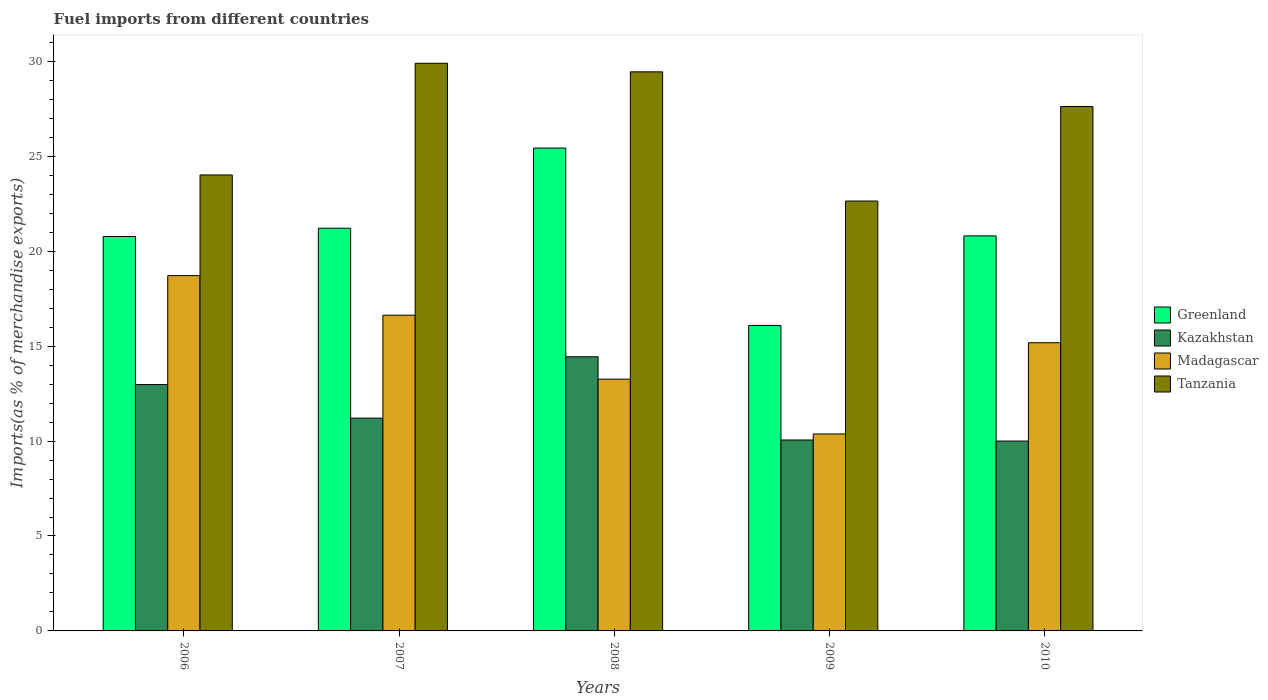How many different coloured bars are there?
Offer a very short reply. 4. How many groups of bars are there?
Your response must be concise. 5. Are the number of bars per tick equal to the number of legend labels?
Offer a very short reply. Yes. Are the number of bars on each tick of the X-axis equal?
Make the answer very short. Yes. How many bars are there on the 5th tick from the left?
Offer a very short reply. 4. How many bars are there on the 5th tick from the right?
Make the answer very short. 4. What is the label of the 1st group of bars from the left?
Offer a very short reply. 2006. In how many cases, is the number of bars for a given year not equal to the number of legend labels?
Your answer should be compact. 0. What is the percentage of imports to different countries in Tanzania in 2007?
Ensure brevity in your answer.  29.9. Across all years, what is the maximum percentage of imports to different countries in Tanzania?
Your answer should be very brief. 29.9. Across all years, what is the minimum percentage of imports to different countries in Greenland?
Provide a short and direct response. 16.09. In which year was the percentage of imports to different countries in Madagascar maximum?
Offer a terse response. 2006. In which year was the percentage of imports to different countries in Madagascar minimum?
Your response must be concise. 2009. What is the total percentage of imports to different countries in Madagascar in the graph?
Make the answer very short. 74.16. What is the difference between the percentage of imports to different countries in Greenland in 2008 and that in 2009?
Offer a very short reply. 9.34. What is the difference between the percentage of imports to different countries in Tanzania in 2009 and the percentage of imports to different countries in Kazakhstan in 2006?
Make the answer very short. 9.66. What is the average percentage of imports to different countries in Madagascar per year?
Keep it short and to the point. 14.83. In the year 2010, what is the difference between the percentage of imports to different countries in Tanzania and percentage of imports to different countries in Madagascar?
Your answer should be very brief. 12.44. In how many years, is the percentage of imports to different countries in Tanzania greater than 12 %?
Provide a short and direct response. 5. What is the ratio of the percentage of imports to different countries in Tanzania in 2006 to that in 2010?
Give a very brief answer. 0.87. Is the percentage of imports to different countries in Madagascar in 2006 less than that in 2007?
Offer a terse response. No. What is the difference between the highest and the second highest percentage of imports to different countries in Kazakhstan?
Your answer should be very brief. 1.46. What is the difference between the highest and the lowest percentage of imports to different countries in Tanzania?
Make the answer very short. 7.26. Is it the case that in every year, the sum of the percentage of imports to different countries in Tanzania and percentage of imports to different countries in Kazakhstan is greater than the sum of percentage of imports to different countries in Greenland and percentage of imports to different countries in Madagascar?
Give a very brief answer. Yes. What does the 1st bar from the left in 2006 represents?
Offer a terse response. Greenland. What does the 1st bar from the right in 2009 represents?
Keep it short and to the point. Tanzania. Are all the bars in the graph horizontal?
Provide a short and direct response. No. What is the difference between two consecutive major ticks on the Y-axis?
Your answer should be compact. 5. Are the values on the major ticks of Y-axis written in scientific E-notation?
Provide a succinct answer. No. What is the title of the graph?
Make the answer very short. Fuel imports from different countries. Does "Zambia" appear as one of the legend labels in the graph?
Your answer should be very brief. No. What is the label or title of the X-axis?
Give a very brief answer. Years. What is the label or title of the Y-axis?
Offer a very short reply. Imports(as % of merchandise exports). What is the Imports(as % of merchandise exports) in Greenland in 2006?
Ensure brevity in your answer.  20.77. What is the Imports(as % of merchandise exports) of Kazakhstan in 2006?
Ensure brevity in your answer.  12.98. What is the Imports(as % of merchandise exports) in Madagascar in 2006?
Keep it short and to the point. 18.71. What is the Imports(as % of merchandise exports) of Tanzania in 2006?
Your answer should be compact. 24.02. What is the Imports(as % of merchandise exports) in Greenland in 2007?
Provide a succinct answer. 21.21. What is the Imports(as % of merchandise exports) in Kazakhstan in 2007?
Ensure brevity in your answer.  11.21. What is the Imports(as % of merchandise exports) in Madagascar in 2007?
Provide a succinct answer. 16.63. What is the Imports(as % of merchandise exports) in Tanzania in 2007?
Provide a short and direct response. 29.9. What is the Imports(as % of merchandise exports) in Greenland in 2008?
Your answer should be very brief. 25.43. What is the Imports(as % of merchandise exports) in Kazakhstan in 2008?
Provide a short and direct response. 14.44. What is the Imports(as % of merchandise exports) of Madagascar in 2008?
Offer a terse response. 13.26. What is the Imports(as % of merchandise exports) in Tanzania in 2008?
Make the answer very short. 29.45. What is the Imports(as % of merchandise exports) of Greenland in 2009?
Keep it short and to the point. 16.09. What is the Imports(as % of merchandise exports) in Kazakhstan in 2009?
Your answer should be very brief. 10.06. What is the Imports(as % of merchandise exports) in Madagascar in 2009?
Give a very brief answer. 10.37. What is the Imports(as % of merchandise exports) of Tanzania in 2009?
Keep it short and to the point. 22.64. What is the Imports(as % of merchandise exports) of Greenland in 2010?
Give a very brief answer. 20.81. What is the Imports(as % of merchandise exports) in Kazakhstan in 2010?
Provide a short and direct response. 10. What is the Imports(as % of merchandise exports) of Madagascar in 2010?
Offer a very short reply. 15.18. What is the Imports(as % of merchandise exports) of Tanzania in 2010?
Offer a terse response. 27.62. Across all years, what is the maximum Imports(as % of merchandise exports) of Greenland?
Offer a terse response. 25.43. Across all years, what is the maximum Imports(as % of merchandise exports) of Kazakhstan?
Provide a short and direct response. 14.44. Across all years, what is the maximum Imports(as % of merchandise exports) of Madagascar?
Offer a very short reply. 18.71. Across all years, what is the maximum Imports(as % of merchandise exports) in Tanzania?
Your response must be concise. 29.9. Across all years, what is the minimum Imports(as % of merchandise exports) in Greenland?
Provide a succinct answer. 16.09. Across all years, what is the minimum Imports(as % of merchandise exports) in Kazakhstan?
Give a very brief answer. 10. Across all years, what is the minimum Imports(as % of merchandise exports) of Madagascar?
Offer a terse response. 10.37. Across all years, what is the minimum Imports(as % of merchandise exports) in Tanzania?
Your answer should be compact. 22.64. What is the total Imports(as % of merchandise exports) in Greenland in the graph?
Provide a short and direct response. 104.31. What is the total Imports(as % of merchandise exports) of Kazakhstan in the graph?
Offer a very short reply. 58.68. What is the total Imports(as % of merchandise exports) in Madagascar in the graph?
Offer a very short reply. 74.16. What is the total Imports(as % of merchandise exports) of Tanzania in the graph?
Your answer should be compact. 133.62. What is the difference between the Imports(as % of merchandise exports) in Greenland in 2006 and that in 2007?
Give a very brief answer. -0.44. What is the difference between the Imports(as % of merchandise exports) of Kazakhstan in 2006 and that in 2007?
Give a very brief answer. 1.77. What is the difference between the Imports(as % of merchandise exports) of Madagascar in 2006 and that in 2007?
Ensure brevity in your answer.  2.09. What is the difference between the Imports(as % of merchandise exports) of Tanzania in 2006 and that in 2007?
Provide a short and direct response. -5.88. What is the difference between the Imports(as % of merchandise exports) in Greenland in 2006 and that in 2008?
Offer a terse response. -4.66. What is the difference between the Imports(as % of merchandise exports) in Kazakhstan in 2006 and that in 2008?
Make the answer very short. -1.46. What is the difference between the Imports(as % of merchandise exports) in Madagascar in 2006 and that in 2008?
Give a very brief answer. 5.45. What is the difference between the Imports(as % of merchandise exports) of Tanzania in 2006 and that in 2008?
Offer a terse response. -5.43. What is the difference between the Imports(as % of merchandise exports) in Greenland in 2006 and that in 2009?
Ensure brevity in your answer.  4.69. What is the difference between the Imports(as % of merchandise exports) in Kazakhstan in 2006 and that in 2009?
Provide a short and direct response. 2.92. What is the difference between the Imports(as % of merchandise exports) of Madagascar in 2006 and that in 2009?
Give a very brief answer. 8.34. What is the difference between the Imports(as % of merchandise exports) in Tanzania in 2006 and that in 2009?
Keep it short and to the point. 1.37. What is the difference between the Imports(as % of merchandise exports) in Greenland in 2006 and that in 2010?
Give a very brief answer. -0.03. What is the difference between the Imports(as % of merchandise exports) of Kazakhstan in 2006 and that in 2010?
Your answer should be compact. 2.98. What is the difference between the Imports(as % of merchandise exports) in Madagascar in 2006 and that in 2010?
Offer a very short reply. 3.54. What is the difference between the Imports(as % of merchandise exports) of Tanzania in 2006 and that in 2010?
Your answer should be very brief. -3.6. What is the difference between the Imports(as % of merchandise exports) in Greenland in 2007 and that in 2008?
Your answer should be compact. -4.22. What is the difference between the Imports(as % of merchandise exports) in Kazakhstan in 2007 and that in 2008?
Keep it short and to the point. -3.23. What is the difference between the Imports(as % of merchandise exports) in Madagascar in 2007 and that in 2008?
Keep it short and to the point. 3.37. What is the difference between the Imports(as % of merchandise exports) in Tanzania in 2007 and that in 2008?
Offer a terse response. 0.45. What is the difference between the Imports(as % of merchandise exports) in Greenland in 2007 and that in 2009?
Your response must be concise. 5.12. What is the difference between the Imports(as % of merchandise exports) in Kazakhstan in 2007 and that in 2009?
Keep it short and to the point. 1.15. What is the difference between the Imports(as % of merchandise exports) of Madagascar in 2007 and that in 2009?
Your answer should be very brief. 6.25. What is the difference between the Imports(as % of merchandise exports) of Tanzania in 2007 and that in 2009?
Provide a succinct answer. 7.26. What is the difference between the Imports(as % of merchandise exports) in Greenland in 2007 and that in 2010?
Provide a short and direct response. 0.4. What is the difference between the Imports(as % of merchandise exports) of Kazakhstan in 2007 and that in 2010?
Offer a terse response. 1.21. What is the difference between the Imports(as % of merchandise exports) of Madagascar in 2007 and that in 2010?
Your answer should be compact. 1.45. What is the difference between the Imports(as % of merchandise exports) in Tanzania in 2007 and that in 2010?
Offer a terse response. 2.28. What is the difference between the Imports(as % of merchandise exports) in Greenland in 2008 and that in 2009?
Offer a terse response. 9.34. What is the difference between the Imports(as % of merchandise exports) of Kazakhstan in 2008 and that in 2009?
Offer a very short reply. 4.38. What is the difference between the Imports(as % of merchandise exports) in Madagascar in 2008 and that in 2009?
Offer a very short reply. 2.89. What is the difference between the Imports(as % of merchandise exports) in Tanzania in 2008 and that in 2009?
Your answer should be compact. 6.8. What is the difference between the Imports(as % of merchandise exports) of Greenland in 2008 and that in 2010?
Offer a terse response. 4.62. What is the difference between the Imports(as % of merchandise exports) of Kazakhstan in 2008 and that in 2010?
Offer a very short reply. 4.44. What is the difference between the Imports(as % of merchandise exports) in Madagascar in 2008 and that in 2010?
Provide a succinct answer. -1.92. What is the difference between the Imports(as % of merchandise exports) in Tanzania in 2008 and that in 2010?
Give a very brief answer. 1.83. What is the difference between the Imports(as % of merchandise exports) of Greenland in 2009 and that in 2010?
Provide a succinct answer. -4.72. What is the difference between the Imports(as % of merchandise exports) in Kazakhstan in 2009 and that in 2010?
Your answer should be compact. 0.06. What is the difference between the Imports(as % of merchandise exports) in Madagascar in 2009 and that in 2010?
Give a very brief answer. -4.8. What is the difference between the Imports(as % of merchandise exports) of Tanzania in 2009 and that in 2010?
Offer a terse response. -4.98. What is the difference between the Imports(as % of merchandise exports) of Greenland in 2006 and the Imports(as % of merchandise exports) of Kazakhstan in 2007?
Your answer should be very brief. 9.57. What is the difference between the Imports(as % of merchandise exports) in Greenland in 2006 and the Imports(as % of merchandise exports) in Madagascar in 2007?
Provide a succinct answer. 4.15. What is the difference between the Imports(as % of merchandise exports) in Greenland in 2006 and the Imports(as % of merchandise exports) in Tanzania in 2007?
Ensure brevity in your answer.  -9.12. What is the difference between the Imports(as % of merchandise exports) of Kazakhstan in 2006 and the Imports(as % of merchandise exports) of Madagascar in 2007?
Offer a terse response. -3.65. What is the difference between the Imports(as % of merchandise exports) in Kazakhstan in 2006 and the Imports(as % of merchandise exports) in Tanzania in 2007?
Give a very brief answer. -16.92. What is the difference between the Imports(as % of merchandise exports) in Madagascar in 2006 and the Imports(as % of merchandise exports) in Tanzania in 2007?
Provide a short and direct response. -11.18. What is the difference between the Imports(as % of merchandise exports) in Greenland in 2006 and the Imports(as % of merchandise exports) in Kazakhstan in 2008?
Provide a succinct answer. 6.33. What is the difference between the Imports(as % of merchandise exports) in Greenland in 2006 and the Imports(as % of merchandise exports) in Madagascar in 2008?
Keep it short and to the point. 7.51. What is the difference between the Imports(as % of merchandise exports) in Greenland in 2006 and the Imports(as % of merchandise exports) in Tanzania in 2008?
Provide a succinct answer. -8.67. What is the difference between the Imports(as % of merchandise exports) in Kazakhstan in 2006 and the Imports(as % of merchandise exports) in Madagascar in 2008?
Your answer should be compact. -0.28. What is the difference between the Imports(as % of merchandise exports) in Kazakhstan in 2006 and the Imports(as % of merchandise exports) in Tanzania in 2008?
Provide a succinct answer. -16.47. What is the difference between the Imports(as % of merchandise exports) in Madagascar in 2006 and the Imports(as % of merchandise exports) in Tanzania in 2008?
Make the answer very short. -10.73. What is the difference between the Imports(as % of merchandise exports) of Greenland in 2006 and the Imports(as % of merchandise exports) of Kazakhstan in 2009?
Provide a succinct answer. 10.72. What is the difference between the Imports(as % of merchandise exports) of Greenland in 2006 and the Imports(as % of merchandise exports) of Madagascar in 2009?
Your response must be concise. 10.4. What is the difference between the Imports(as % of merchandise exports) in Greenland in 2006 and the Imports(as % of merchandise exports) in Tanzania in 2009?
Give a very brief answer. -1.87. What is the difference between the Imports(as % of merchandise exports) of Kazakhstan in 2006 and the Imports(as % of merchandise exports) of Madagascar in 2009?
Offer a very short reply. 2.6. What is the difference between the Imports(as % of merchandise exports) in Kazakhstan in 2006 and the Imports(as % of merchandise exports) in Tanzania in 2009?
Offer a very short reply. -9.66. What is the difference between the Imports(as % of merchandise exports) of Madagascar in 2006 and the Imports(as % of merchandise exports) of Tanzania in 2009?
Provide a succinct answer. -3.93. What is the difference between the Imports(as % of merchandise exports) in Greenland in 2006 and the Imports(as % of merchandise exports) in Kazakhstan in 2010?
Provide a short and direct response. 10.77. What is the difference between the Imports(as % of merchandise exports) of Greenland in 2006 and the Imports(as % of merchandise exports) of Madagascar in 2010?
Provide a short and direct response. 5.6. What is the difference between the Imports(as % of merchandise exports) in Greenland in 2006 and the Imports(as % of merchandise exports) in Tanzania in 2010?
Make the answer very short. -6.85. What is the difference between the Imports(as % of merchandise exports) of Kazakhstan in 2006 and the Imports(as % of merchandise exports) of Madagascar in 2010?
Give a very brief answer. -2.2. What is the difference between the Imports(as % of merchandise exports) in Kazakhstan in 2006 and the Imports(as % of merchandise exports) in Tanzania in 2010?
Your answer should be very brief. -14.64. What is the difference between the Imports(as % of merchandise exports) in Madagascar in 2006 and the Imports(as % of merchandise exports) in Tanzania in 2010?
Offer a very short reply. -8.91. What is the difference between the Imports(as % of merchandise exports) in Greenland in 2007 and the Imports(as % of merchandise exports) in Kazakhstan in 2008?
Provide a short and direct response. 6.77. What is the difference between the Imports(as % of merchandise exports) of Greenland in 2007 and the Imports(as % of merchandise exports) of Madagascar in 2008?
Offer a very short reply. 7.95. What is the difference between the Imports(as % of merchandise exports) of Greenland in 2007 and the Imports(as % of merchandise exports) of Tanzania in 2008?
Offer a very short reply. -8.24. What is the difference between the Imports(as % of merchandise exports) of Kazakhstan in 2007 and the Imports(as % of merchandise exports) of Madagascar in 2008?
Ensure brevity in your answer.  -2.05. What is the difference between the Imports(as % of merchandise exports) in Kazakhstan in 2007 and the Imports(as % of merchandise exports) in Tanzania in 2008?
Keep it short and to the point. -18.24. What is the difference between the Imports(as % of merchandise exports) of Madagascar in 2007 and the Imports(as % of merchandise exports) of Tanzania in 2008?
Offer a very short reply. -12.82. What is the difference between the Imports(as % of merchandise exports) of Greenland in 2007 and the Imports(as % of merchandise exports) of Kazakhstan in 2009?
Offer a very short reply. 11.15. What is the difference between the Imports(as % of merchandise exports) in Greenland in 2007 and the Imports(as % of merchandise exports) in Madagascar in 2009?
Offer a very short reply. 10.83. What is the difference between the Imports(as % of merchandise exports) of Greenland in 2007 and the Imports(as % of merchandise exports) of Tanzania in 2009?
Your answer should be very brief. -1.43. What is the difference between the Imports(as % of merchandise exports) in Kazakhstan in 2007 and the Imports(as % of merchandise exports) in Madagascar in 2009?
Your answer should be compact. 0.83. What is the difference between the Imports(as % of merchandise exports) of Kazakhstan in 2007 and the Imports(as % of merchandise exports) of Tanzania in 2009?
Provide a short and direct response. -11.43. What is the difference between the Imports(as % of merchandise exports) of Madagascar in 2007 and the Imports(as % of merchandise exports) of Tanzania in 2009?
Keep it short and to the point. -6.01. What is the difference between the Imports(as % of merchandise exports) in Greenland in 2007 and the Imports(as % of merchandise exports) in Kazakhstan in 2010?
Your response must be concise. 11.21. What is the difference between the Imports(as % of merchandise exports) in Greenland in 2007 and the Imports(as % of merchandise exports) in Madagascar in 2010?
Your answer should be compact. 6.03. What is the difference between the Imports(as % of merchandise exports) in Greenland in 2007 and the Imports(as % of merchandise exports) in Tanzania in 2010?
Your answer should be compact. -6.41. What is the difference between the Imports(as % of merchandise exports) in Kazakhstan in 2007 and the Imports(as % of merchandise exports) in Madagascar in 2010?
Give a very brief answer. -3.97. What is the difference between the Imports(as % of merchandise exports) of Kazakhstan in 2007 and the Imports(as % of merchandise exports) of Tanzania in 2010?
Your answer should be very brief. -16.41. What is the difference between the Imports(as % of merchandise exports) in Madagascar in 2007 and the Imports(as % of merchandise exports) in Tanzania in 2010?
Your response must be concise. -10.99. What is the difference between the Imports(as % of merchandise exports) in Greenland in 2008 and the Imports(as % of merchandise exports) in Kazakhstan in 2009?
Offer a terse response. 15.38. What is the difference between the Imports(as % of merchandise exports) of Greenland in 2008 and the Imports(as % of merchandise exports) of Madagascar in 2009?
Your answer should be very brief. 15.06. What is the difference between the Imports(as % of merchandise exports) in Greenland in 2008 and the Imports(as % of merchandise exports) in Tanzania in 2009?
Offer a terse response. 2.79. What is the difference between the Imports(as % of merchandise exports) in Kazakhstan in 2008 and the Imports(as % of merchandise exports) in Madagascar in 2009?
Give a very brief answer. 4.06. What is the difference between the Imports(as % of merchandise exports) in Kazakhstan in 2008 and the Imports(as % of merchandise exports) in Tanzania in 2009?
Your answer should be very brief. -8.2. What is the difference between the Imports(as % of merchandise exports) of Madagascar in 2008 and the Imports(as % of merchandise exports) of Tanzania in 2009?
Ensure brevity in your answer.  -9.38. What is the difference between the Imports(as % of merchandise exports) of Greenland in 2008 and the Imports(as % of merchandise exports) of Kazakhstan in 2010?
Provide a short and direct response. 15.43. What is the difference between the Imports(as % of merchandise exports) of Greenland in 2008 and the Imports(as % of merchandise exports) of Madagascar in 2010?
Provide a succinct answer. 10.25. What is the difference between the Imports(as % of merchandise exports) of Greenland in 2008 and the Imports(as % of merchandise exports) of Tanzania in 2010?
Your answer should be compact. -2.19. What is the difference between the Imports(as % of merchandise exports) in Kazakhstan in 2008 and the Imports(as % of merchandise exports) in Madagascar in 2010?
Offer a very short reply. -0.74. What is the difference between the Imports(as % of merchandise exports) in Kazakhstan in 2008 and the Imports(as % of merchandise exports) in Tanzania in 2010?
Your answer should be very brief. -13.18. What is the difference between the Imports(as % of merchandise exports) of Madagascar in 2008 and the Imports(as % of merchandise exports) of Tanzania in 2010?
Your response must be concise. -14.36. What is the difference between the Imports(as % of merchandise exports) of Greenland in 2009 and the Imports(as % of merchandise exports) of Kazakhstan in 2010?
Offer a very short reply. 6.09. What is the difference between the Imports(as % of merchandise exports) of Greenland in 2009 and the Imports(as % of merchandise exports) of Madagascar in 2010?
Your answer should be compact. 0.91. What is the difference between the Imports(as % of merchandise exports) in Greenland in 2009 and the Imports(as % of merchandise exports) in Tanzania in 2010?
Your answer should be very brief. -11.53. What is the difference between the Imports(as % of merchandise exports) of Kazakhstan in 2009 and the Imports(as % of merchandise exports) of Madagascar in 2010?
Give a very brief answer. -5.12. What is the difference between the Imports(as % of merchandise exports) of Kazakhstan in 2009 and the Imports(as % of merchandise exports) of Tanzania in 2010?
Give a very brief answer. -17.56. What is the difference between the Imports(as % of merchandise exports) in Madagascar in 2009 and the Imports(as % of merchandise exports) in Tanzania in 2010?
Provide a short and direct response. -17.24. What is the average Imports(as % of merchandise exports) in Greenland per year?
Your response must be concise. 20.86. What is the average Imports(as % of merchandise exports) of Kazakhstan per year?
Give a very brief answer. 11.74. What is the average Imports(as % of merchandise exports) of Madagascar per year?
Offer a very short reply. 14.83. What is the average Imports(as % of merchandise exports) in Tanzania per year?
Your response must be concise. 26.72. In the year 2006, what is the difference between the Imports(as % of merchandise exports) of Greenland and Imports(as % of merchandise exports) of Kazakhstan?
Your response must be concise. 7.8. In the year 2006, what is the difference between the Imports(as % of merchandise exports) of Greenland and Imports(as % of merchandise exports) of Madagascar?
Give a very brief answer. 2.06. In the year 2006, what is the difference between the Imports(as % of merchandise exports) in Greenland and Imports(as % of merchandise exports) in Tanzania?
Ensure brevity in your answer.  -3.24. In the year 2006, what is the difference between the Imports(as % of merchandise exports) in Kazakhstan and Imports(as % of merchandise exports) in Madagascar?
Make the answer very short. -5.74. In the year 2006, what is the difference between the Imports(as % of merchandise exports) of Kazakhstan and Imports(as % of merchandise exports) of Tanzania?
Your answer should be compact. -11.04. In the year 2006, what is the difference between the Imports(as % of merchandise exports) of Madagascar and Imports(as % of merchandise exports) of Tanzania?
Your answer should be compact. -5.3. In the year 2007, what is the difference between the Imports(as % of merchandise exports) in Greenland and Imports(as % of merchandise exports) in Kazakhstan?
Your response must be concise. 10. In the year 2007, what is the difference between the Imports(as % of merchandise exports) of Greenland and Imports(as % of merchandise exports) of Madagascar?
Ensure brevity in your answer.  4.58. In the year 2007, what is the difference between the Imports(as % of merchandise exports) in Greenland and Imports(as % of merchandise exports) in Tanzania?
Your answer should be compact. -8.69. In the year 2007, what is the difference between the Imports(as % of merchandise exports) of Kazakhstan and Imports(as % of merchandise exports) of Madagascar?
Keep it short and to the point. -5.42. In the year 2007, what is the difference between the Imports(as % of merchandise exports) in Kazakhstan and Imports(as % of merchandise exports) in Tanzania?
Offer a very short reply. -18.69. In the year 2007, what is the difference between the Imports(as % of merchandise exports) of Madagascar and Imports(as % of merchandise exports) of Tanzania?
Your answer should be very brief. -13.27. In the year 2008, what is the difference between the Imports(as % of merchandise exports) in Greenland and Imports(as % of merchandise exports) in Kazakhstan?
Provide a short and direct response. 10.99. In the year 2008, what is the difference between the Imports(as % of merchandise exports) of Greenland and Imports(as % of merchandise exports) of Madagascar?
Give a very brief answer. 12.17. In the year 2008, what is the difference between the Imports(as % of merchandise exports) of Greenland and Imports(as % of merchandise exports) of Tanzania?
Your response must be concise. -4.01. In the year 2008, what is the difference between the Imports(as % of merchandise exports) of Kazakhstan and Imports(as % of merchandise exports) of Madagascar?
Ensure brevity in your answer.  1.18. In the year 2008, what is the difference between the Imports(as % of merchandise exports) in Kazakhstan and Imports(as % of merchandise exports) in Tanzania?
Your answer should be compact. -15.01. In the year 2008, what is the difference between the Imports(as % of merchandise exports) in Madagascar and Imports(as % of merchandise exports) in Tanzania?
Provide a succinct answer. -16.18. In the year 2009, what is the difference between the Imports(as % of merchandise exports) of Greenland and Imports(as % of merchandise exports) of Kazakhstan?
Keep it short and to the point. 6.03. In the year 2009, what is the difference between the Imports(as % of merchandise exports) of Greenland and Imports(as % of merchandise exports) of Madagascar?
Provide a succinct answer. 5.71. In the year 2009, what is the difference between the Imports(as % of merchandise exports) in Greenland and Imports(as % of merchandise exports) in Tanzania?
Keep it short and to the point. -6.55. In the year 2009, what is the difference between the Imports(as % of merchandise exports) of Kazakhstan and Imports(as % of merchandise exports) of Madagascar?
Give a very brief answer. -0.32. In the year 2009, what is the difference between the Imports(as % of merchandise exports) in Kazakhstan and Imports(as % of merchandise exports) in Tanzania?
Offer a terse response. -12.59. In the year 2009, what is the difference between the Imports(as % of merchandise exports) of Madagascar and Imports(as % of merchandise exports) of Tanzania?
Provide a succinct answer. -12.27. In the year 2010, what is the difference between the Imports(as % of merchandise exports) in Greenland and Imports(as % of merchandise exports) in Kazakhstan?
Offer a terse response. 10.81. In the year 2010, what is the difference between the Imports(as % of merchandise exports) of Greenland and Imports(as % of merchandise exports) of Madagascar?
Provide a short and direct response. 5.63. In the year 2010, what is the difference between the Imports(as % of merchandise exports) of Greenland and Imports(as % of merchandise exports) of Tanzania?
Offer a terse response. -6.81. In the year 2010, what is the difference between the Imports(as % of merchandise exports) in Kazakhstan and Imports(as % of merchandise exports) in Madagascar?
Make the answer very short. -5.18. In the year 2010, what is the difference between the Imports(as % of merchandise exports) in Kazakhstan and Imports(as % of merchandise exports) in Tanzania?
Your response must be concise. -17.62. In the year 2010, what is the difference between the Imports(as % of merchandise exports) in Madagascar and Imports(as % of merchandise exports) in Tanzania?
Give a very brief answer. -12.44. What is the ratio of the Imports(as % of merchandise exports) in Greenland in 2006 to that in 2007?
Provide a succinct answer. 0.98. What is the ratio of the Imports(as % of merchandise exports) in Kazakhstan in 2006 to that in 2007?
Your response must be concise. 1.16. What is the ratio of the Imports(as % of merchandise exports) of Madagascar in 2006 to that in 2007?
Give a very brief answer. 1.13. What is the ratio of the Imports(as % of merchandise exports) of Tanzania in 2006 to that in 2007?
Provide a succinct answer. 0.8. What is the ratio of the Imports(as % of merchandise exports) of Greenland in 2006 to that in 2008?
Your response must be concise. 0.82. What is the ratio of the Imports(as % of merchandise exports) in Kazakhstan in 2006 to that in 2008?
Give a very brief answer. 0.9. What is the ratio of the Imports(as % of merchandise exports) in Madagascar in 2006 to that in 2008?
Ensure brevity in your answer.  1.41. What is the ratio of the Imports(as % of merchandise exports) of Tanzania in 2006 to that in 2008?
Provide a succinct answer. 0.82. What is the ratio of the Imports(as % of merchandise exports) of Greenland in 2006 to that in 2009?
Give a very brief answer. 1.29. What is the ratio of the Imports(as % of merchandise exports) in Kazakhstan in 2006 to that in 2009?
Offer a terse response. 1.29. What is the ratio of the Imports(as % of merchandise exports) in Madagascar in 2006 to that in 2009?
Keep it short and to the point. 1.8. What is the ratio of the Imports(as % of merchandise exports) of Tanzania in 2006 to that in 2009?
Provide a succinct answer. 1.06. What is the ratio of the Imports(as % of merchandise exports) of Kazakhstan in 2006 to that in 2010?
Make the answer very short. 1.3. What is the ratio of the Imports(as % of merchandise exports) of Madagascar in 2006 to that in 2010?
Make the answer very short. 1.23. What is the ratio of the Imports(as % of merchandise exports) of Tanzania in 2006 to that in 2010?
Offer a terse response. 0.87. What is the ratio of the Imports(as % of merchandise exports) of Greenland in 2007 to that in 2008?
Provide a short and direct response. 0.83. What is the ratio of the Imports(as % of merchandise exports) of Kazakhstan in 2007 to that in 2008?
Ensure brevity in your answer.  0.78. What is the ratio of the Imports(as % of merchandise exports) in Madagascar in 2007 to that in 2008?
Offer a terse response. 1.25. What is the ratio of the Imports(as % of merchandise exports) in Tanzania in 2007 to that in 2008?
Offer a terse response. 1.02. What is the ratio of the Imports(as % of merchandise exports) of Greenland in 2007 to that in 2009?
Make the answer very short. 1.32. What is the ratio of the Imports(as % of merchandise exports) of Kazakhstan in 2007 to that in 2009?
Give a very brief answer. 1.11. What is the ratio of the Imports(as % of merchandise exports) of Madagascar in 2007 to that in 2009?
Ensure brevity in your answer.  1.6. What is the ratio of the Imports(as % of merchandise exports) of Tanzania in 2007 to that in 2009?
Make the answer very short. 1.32. What is the ratio of the Imports(as % of merchandise exports) in Greenland in 2007 to that in 2010?
Keep it short and to the point. 1.02. What is the ratio of the Imports(as % of merchandise exports) in Kazakhstan in 2007 to that in 2010?
Your response must be concise. 1.12. What is the ratio of the Imports(as % of merchandise exports) in Madagascar in 2007 to that in 2010?
Your answer should be very brief. 1.1. What is the ratio of the Imports(as % of merchandise exports) of Tanzania in 2007 to that in 2010?
Your answer should be very brief. 1.08. What is the ratio of the Imports(as % of merchandise exports) in Greenland in 2008 to that in 2009?
Ensure brevity in your answer.  1.58. What is the ratio of the Imports(as % of merchandise exports) in Kazakhstan in 2008 to that in 2009?
Provide a short and direct response. 1.44. What is the ratio of the Imports(as % of merchandise exports) in Madagascar in 2008 to that in 2009?
Keep it short and to the point. 1.28. What is the ratio of the Imports(as % of merchandise exports) of Tanzania in 2008 to that in 2009?
Keep it short and to the point. 1.3. What is the ratio of the Imports(as % of merchandise exports) in Greenland in 2008 to that in 2010?
Your answer should be very brief. 1.22. What is the ratio of the Imports(as % of merchandise exports) in Kazakhstan in 2008 to that in 2010?
Provide a succinct answer. 1.44. What is the ratio of the Imports(as % of merchandise exports) in Madagascar in 2008 to that in 2010?
Ensure brevity in your answer.  0.87. What is the ratio of the Imports(as % of merchandise exports) in Tanzania in 2008 to that in 2010?
Offer a very short reply. 1.07. What is the ratio of the Imports(as % of merchandise exports) in Greenland in 2009 to that in 2010?
Your response must be concise. 0.77. What is the ratio of the Imports(as % of merchandise exports) in Kazakhstan in 2009 to that in 2010?
Your answer should be compact. 1.01. What is the ratio of the Imports(as % of merchandise exports) of Madagascar in 2009 to that in 2010?
Give a very brief answer. 0.68. What is the ratio of the Imports(as % of merchandise exports) of Tanzania in 2009 to that in 2010?
Your answer should be very brief. 0.82. What is the difference between the highest and the second highest Imports(as % of merchandise exports) in Greenland?
Offer a terse response. 4.22. What is the difference between the highest and the second highest Imports(as % of merchandise exports) of Kazakhstan?
Provide a short and direct response. 1.46. What is the difference between the highest and the second highest Imports(as % of merchandise exports) in Madagascar?
Keep it short and to the point. 2.09. What is the difference between the highest and the second highest Imports(as % of merchandise exports) in Tanzania?
Offer a very short reply. 0.45. What is the difference between the highest and the lowest Imports(as % of merchandise exports) of Greenland?
Keep it short and to the point. 9.34. What is the difference between the highest and the lowest Imports(as % of merchandise exports) of Kazakhstan?
Provide a succinct answer. 4.44. What is the difference between the highest and the lowest Imports(as % of merchandise exports) in Madagascar?
Offer a very short reply. 8.34. What is the difference between the highest and the lowest Imports(as % of merchandise exports) in Tanzania?
Offer a very short reply. 7.26. 